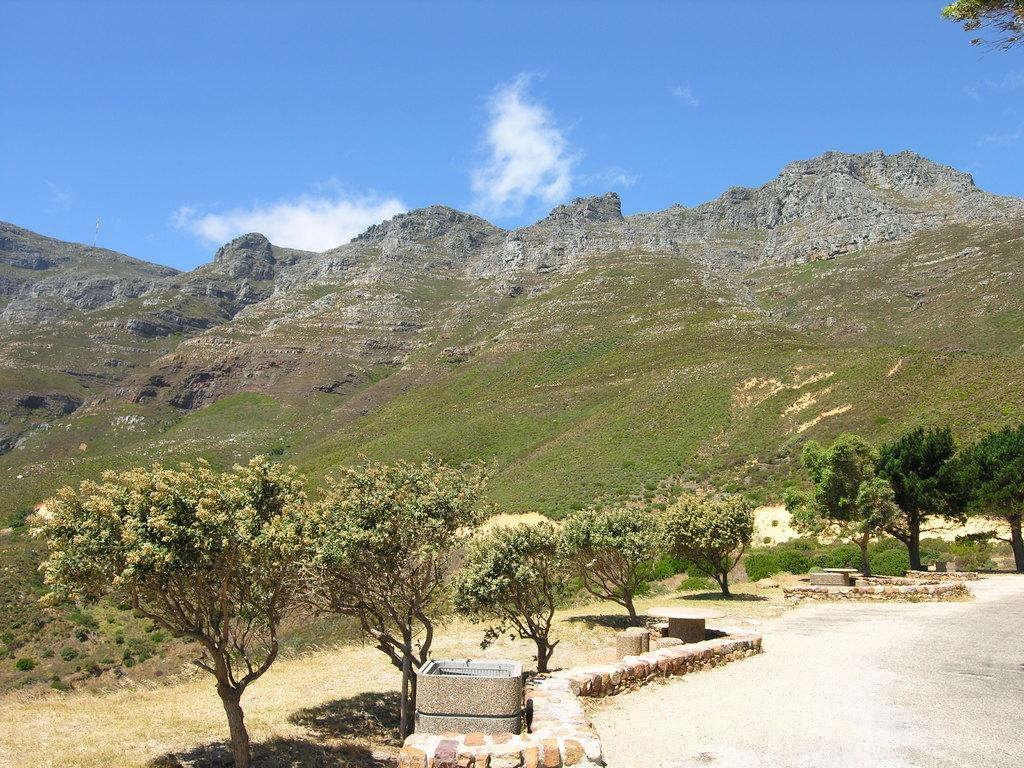What type of vegetation can be seen in the image? There are trees and plants in the image. What type of natural feature is present in the image? There is a hill in the image. What is visible in the sky in the image? The sky is visible in the image, and clouds are present. What other elements can be found on the ground in the image? There are stones in the image. Can you see any planes flying over the hill in the image? There are no planes visible in the image. Is there a goat grazing on the hill in the image? There is no goat present in the image. 